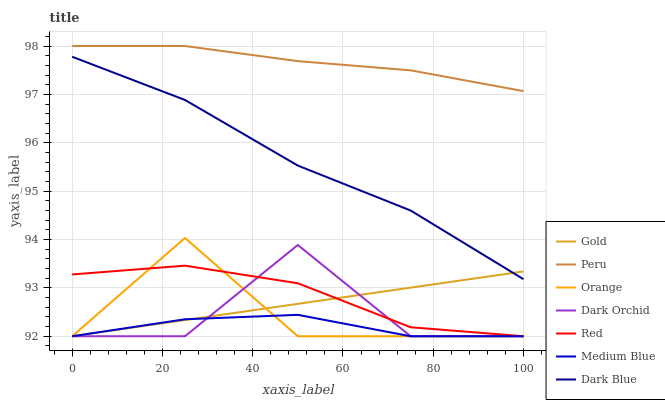Does Medium Blue have the minimum area under the curve?
Answer yes or no. Yes. Does Peru have the maximum area under the curve?
Answer yes or no. Yes. Does Dark Orchid have the minimum area under the curve?
Answer yes or no. No. Does Dark Orchid have the maximum area under the curve?
Answer yes or no. No. Is Gold the smoothest?
Answer yes or no. Yes. Is Dark Orchid the roughest?
Answer yes or no. Yes. Is Medium Blue the smoothest?
Answer yes or no. No. Is Medium Blue the roughest?
Answer yes or no. No. Does Gold have the lowest value?
Answer yes or no. Yes. Does Dark Blue have the lowest value?
Answer yes or no. No. Does Peru have the highest value?
Answer yes or no. Yes. Does Dark Orchid have the highest value?
Answer yes or no. No. Is Medium Blue less than Dark Blue?
Answer yes or no. Yes. Is Dark Blue greater than Medium Blue?
Answer yes or no. Yes. Does Gold intersect Medium Blue?
Answer yes or no. Yes. Is Gold less than Medium Blue?
Answer yes or no. No. Is Gold greater than Medium Blue?
Answer yes or no. No. Does Medium Blue intersect Dark Blue?
Answer yes or no. No. 